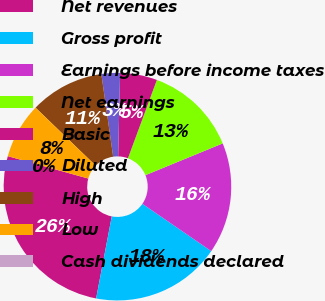Convert chart to OTSL. <chart><loc_0><loc_0><loc_500><loc_500><pie_chart><fcel>Net revenues<fcel>Gross profit<fcel>Earnings before income taxes<fcel>Net earnings<fcel>Basic<fcel>Diluted<fcel>High<fcel>Low<fcel>Cash dividends declared<nl><fcel>26.32%<fcel>18.42%<fcel>15.79%<fcel>13.16%<fcel>5.26%<fcel>2.63%<fcel>10.53%<fcel>7.89%<fcel>0.0%<nl></chart> 